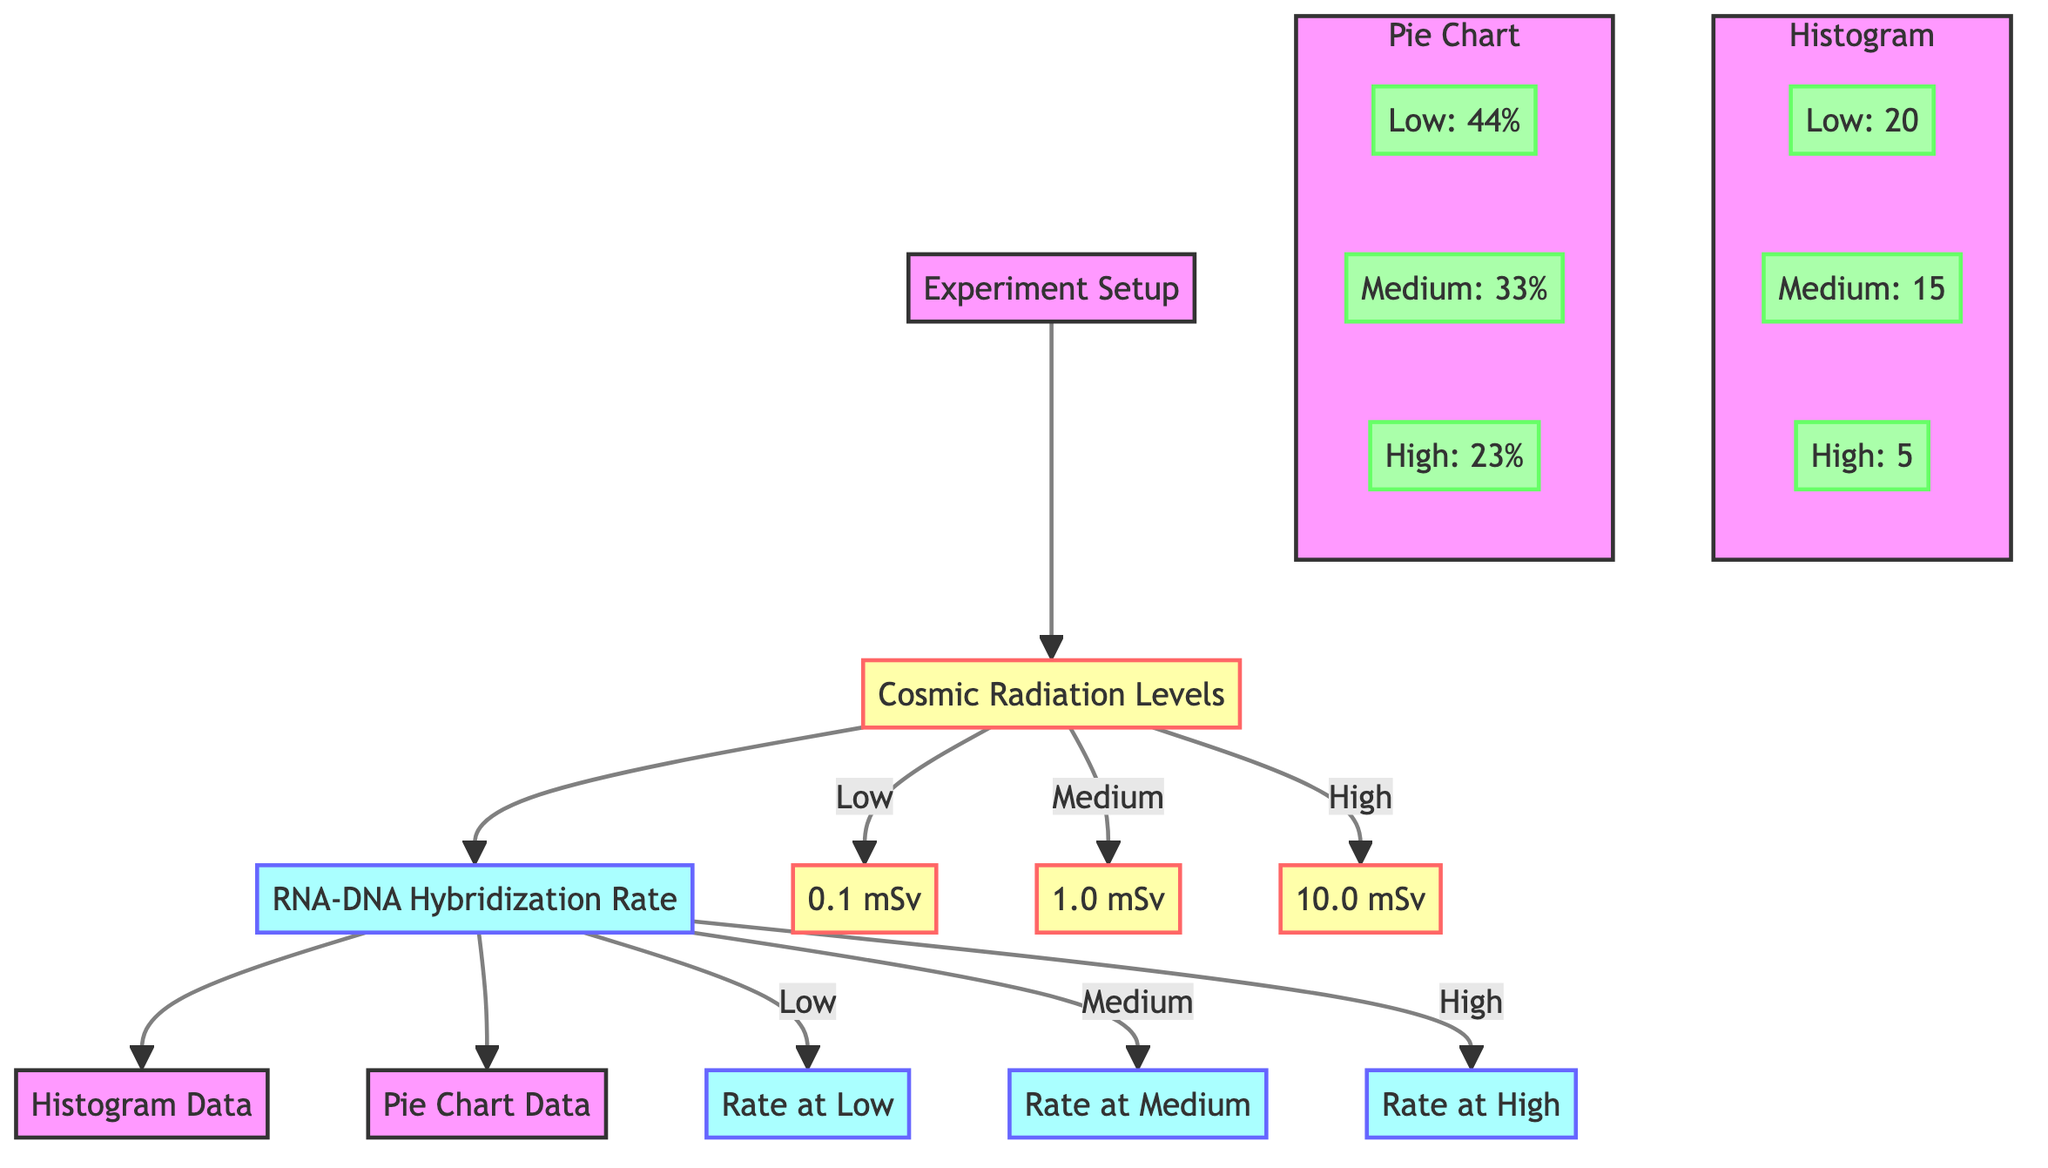What are the cosmic radiation levels represented in the diagram? The diagram shows three levels of cosmic radiation: Low (0.1 mSv), Medium (1.0 mSv), and High (10.0 mSv).
Answer: Low, Medium, High What is the RNA-DNA hybridization rate at Low cosmic radiation? According to the diagram, the hybridization rate at Low cosmic radiation is labeled as "Rate at Low."
Answer: Rate at Low How many experiments are depicted in the diagram? There are three levels of cosmic radiation leading to three hybridization rates, indicating that three experiments are depicted in the diagram.
Answer: 3 What percentage of the total hybridization rate corresponds to Medium cosmic radiation? The diagram shows that Medium cosmic radiation accounts for 33% in the pie chart data.
Answer: 33% What is the value of the RNA-DNA hybridization rate at High cosmic radiation? In the diagram, there is a specific indication for the RNA-DNA hybridization rate at High cosmic radiation, which is "Rate at High."
Answer: Rate at High What does the histogram show for Low cosmic radiation? The histogram shows a value of 20 for Low cosmic radiation under the corresponding data node.
Answer: 20 Which cosmic radiation level has the lowest RNA-DNA hybridization rate? The High cosmic radiation level has the lowest RNA-DNA hybridization rate according to the data presented in the histogram.
Answer: High How does the total hybridization rate change from Low to High cosmic radiation according to the histogram? As we move from Low (20) to Medium (15) and then to High (5), the total hybridization rate decreases.
Answer: Decreases What visual representation is used to show the distribution of hybridization rates? The diagram utilizes both a histogram and a pie chart to represent the distribution of hybridization rates.
Answer: Histogram and Pie Chart 